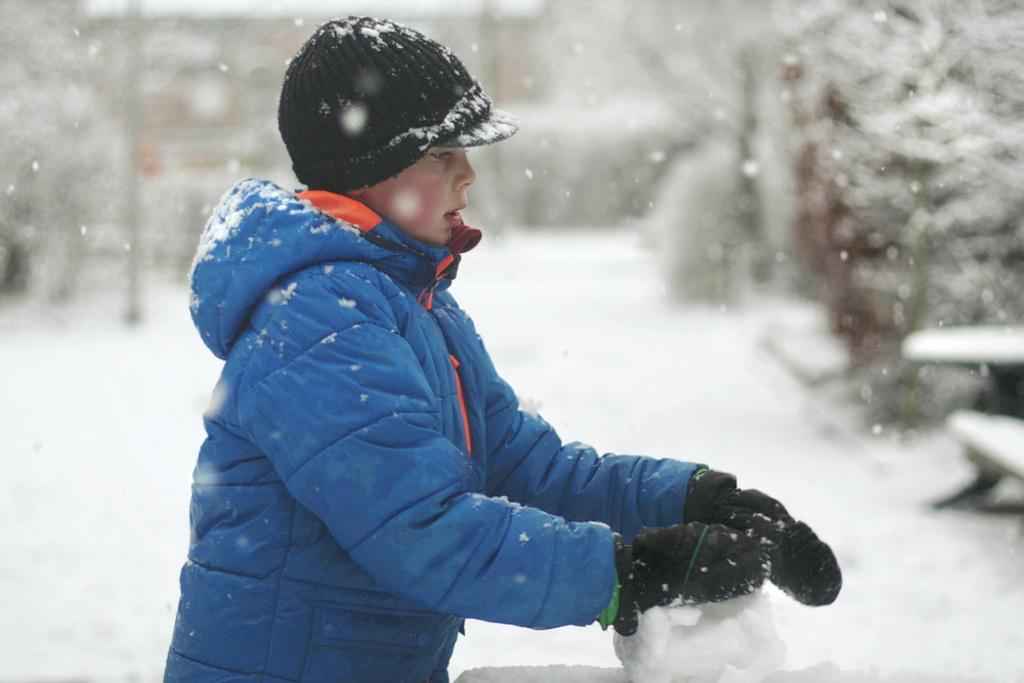What is the person in the image doing? The person is playing with snow in the image. Can you describe the setting of the image? There is snow visible in the background of the image, and the background appears blurry. What type of haircut does the person have in the image? There is no information about the person's haircut in the image, as the focus is on the person playing with snow. 